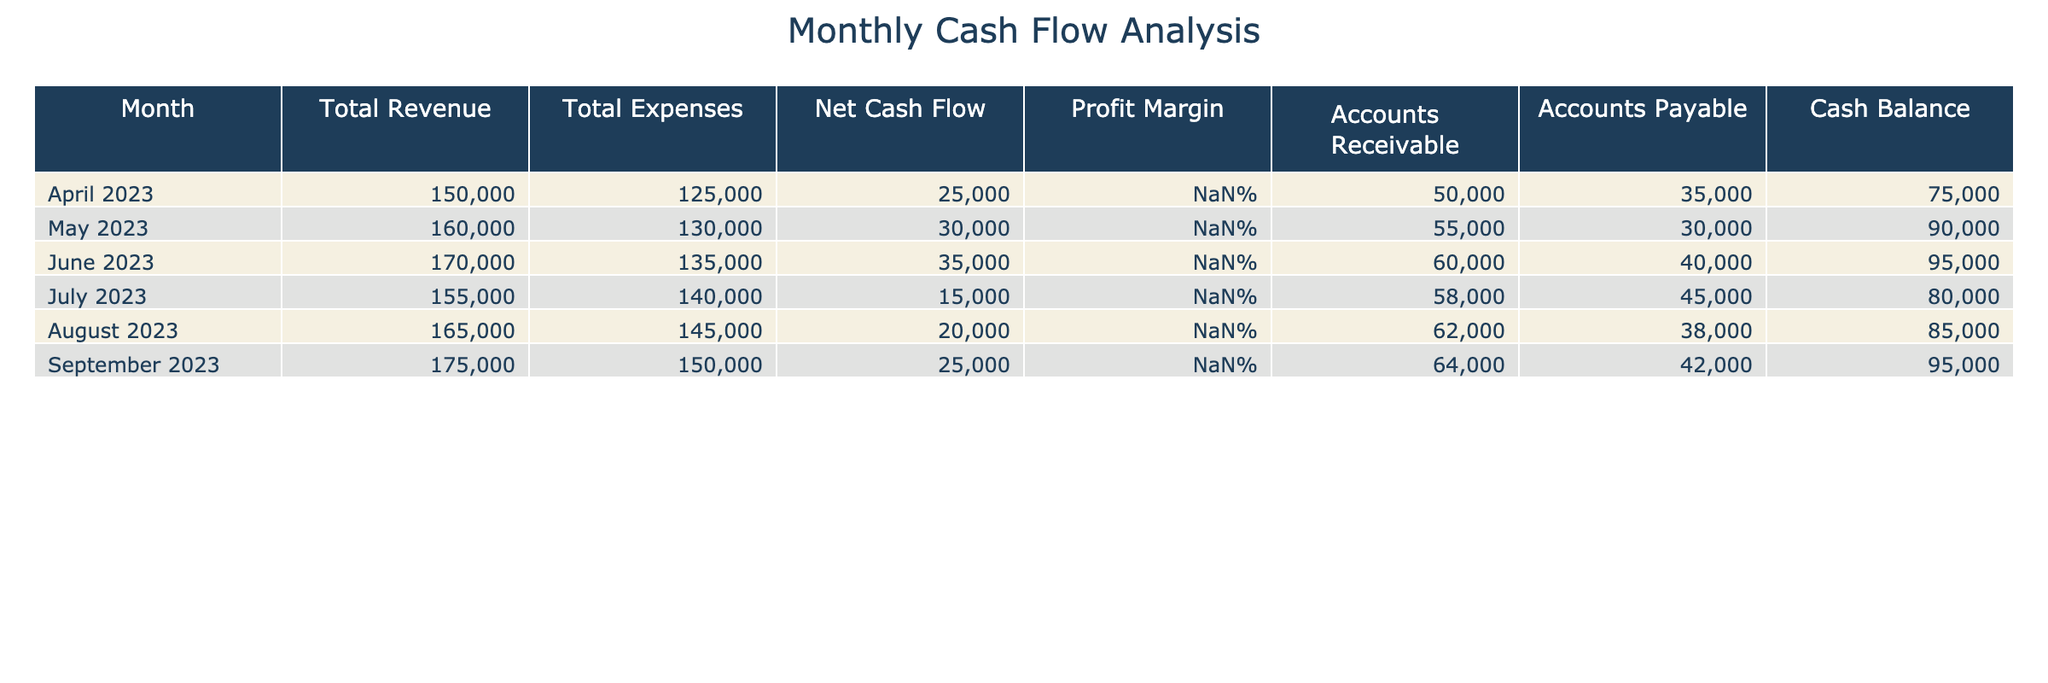What was the net cash flow in June 2023? In the table for June 2023, the Net Cash Flow column shows a value of 35000.
Answer: 35000 What was the profit margin for May 2023? In the table for May 2023, the Profit Margin column displays 18.75%.
Answer: 18.75% What is the total revenue for the months of April, May, and June combined? To find the total revenue for April, May, and June, sum their individual revenues: 150000 (April) + 160000 (May) + 170000 (June) = 480000.
Answer: 480000 Is the average cash balance for the last three months greater than 85000? The cash balances for the last three months are: 80000 (July), 85000 (August), and 95000 (September). Their average is (80000 + 85000 + 95000)/3 = 86666.67, which is greater than 85000.
Answer: Yes How did the total expenses change from April to September? To find the change in total expenses, subtract the value in April from the value in September: 150000 (September) - 125000 (April) = 25000. This indicates that expenses increased by 25000 over these months.
Answer: 25000 What month had the highest profit margin? By inspecting the Profit Margin column, June 2023 has the highest value at 20.59%.
Answer: June 2023 What is the total accounts receivable from April to August? The accounts receivable values from April to August are: 50000 (April), 55000 (May), 60000 (June), 58000 (July), and 62000 (August). Summing these gives: 50000 + 55000 + 60000 + 58000 + 62000 = 285000.
Answer: 285000 Is the net cash flow for August less than the average net cash flow for the six months? The net cash flows are: 25000 (April), 30000 (May), 35000 (June), 15000 (July), 20000 (August), and 25000 (September). The average is (25000 + 30000 + 35000 + 15000 + 20000 + 25000) / 6 = 22500. Since 20000 (August) is greater than 22500, the answer is no.
Answer: No Which month had the lowest total revenue? By checking the Total Revenue column, it shows that April 2023 had the lowest revenue of 150000.
Answer: April 2023 